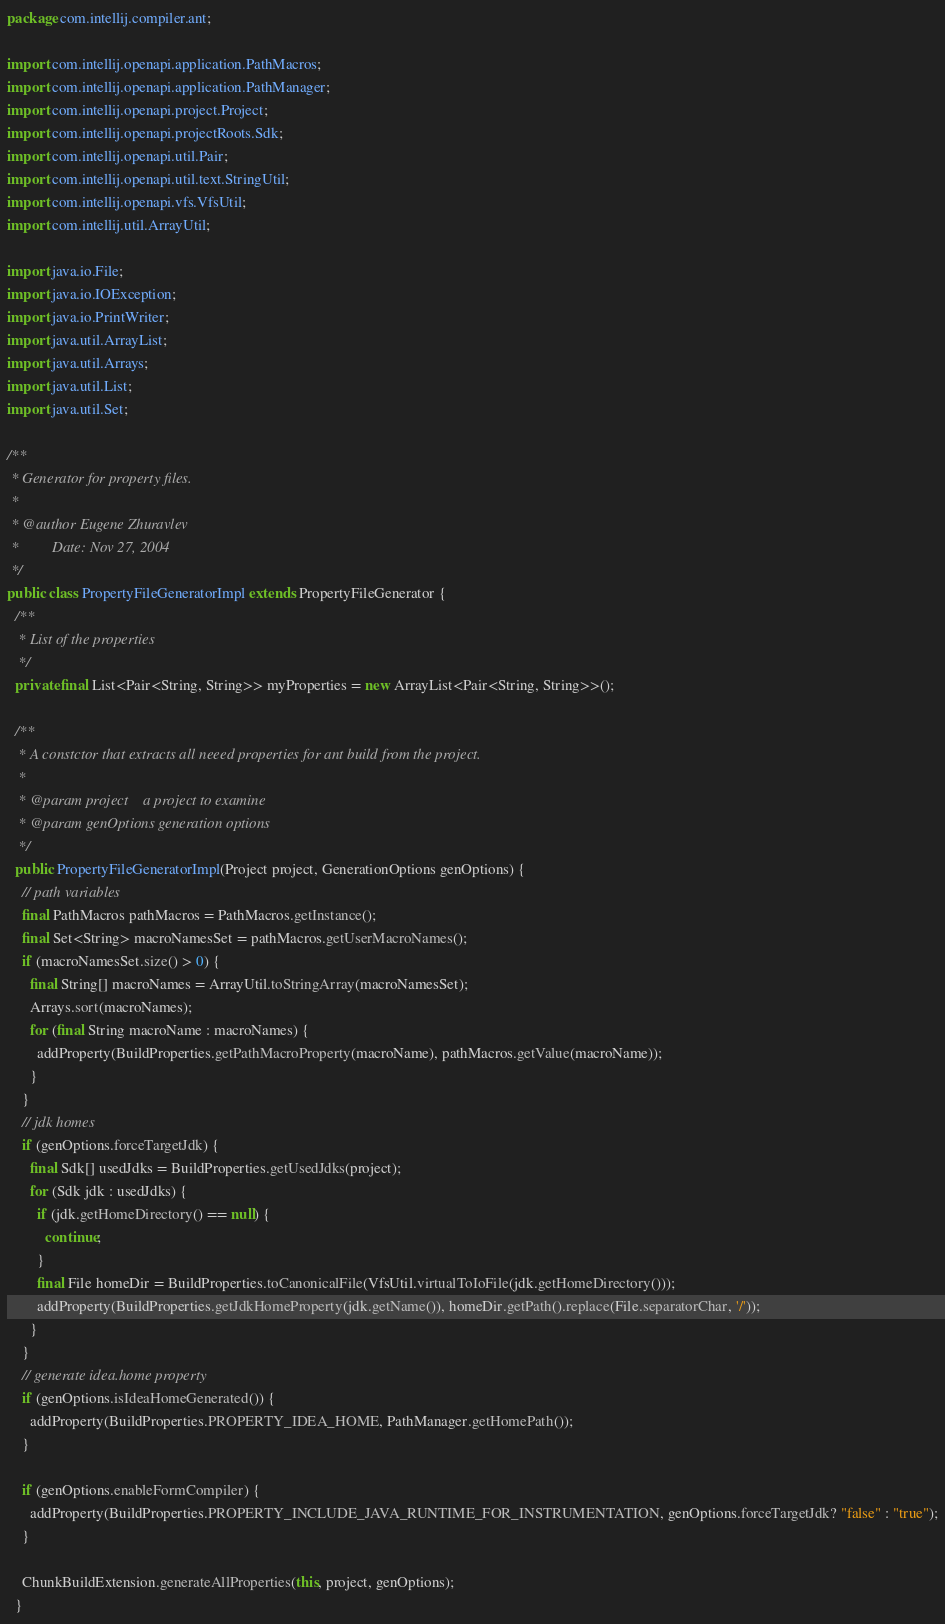Convert code to text. <code><loc_0><loc_0><loc_500><loc_500><_Java_>package com.intellij.compiler.ant;

import com.intellij.openapi.application.PathMacros;
import com.intellij.openapi.application.PathManager;
import com.intellij.openapi.project.Project;
import com.intellij.openapi.projectRoots.Sdk;
import com.intellij.openapi.util.Pair;
import com.intellij.openapi.util.text.StringUtil;
import com.intellij.openapi.vfs.VfsUtil;
import com.intellij.util.ArrayUtil;

import java.io.File;
import java.io.IOException;
import java.io.PrintWriter;
import java.util.ArrayList;
import java.util.Arrays;
import java.util.List;
import java.util.Set;

/**
 * Generator for property files.
 *
 * @author Eugene Zhuravlev
 *         Date: Nov 27, 2004
 */
public class PropertyFileGeneratorImpl extends PropertyFileGenerator {
  /**
   * List of the properties
   */
  private final List<Pair<String, String>> myProperties = new ArrayList<Pair<String, String>>();

  /**
   * A constctor that extracts all neeed properties for ant build from the project.
   *
   * @param project    a project to examine
   * @param genOptions generation options
   */
  public PropertyFileGeneratorImpl(Project project, GenerationOptions genOptions) {
    // path variables
    final PathMacros pathMacros = PathMacros.getInstance();
    final Set<String> macroNamesSet = pathMacros.getUserMacroNames();
    if (macroNamesSet.size() > 0) {
      final String[] macroNames = ArrayUtil.toStringArray(macroNamesSet);
      Arrays.sort(macroNames);
      for (final String macroName : macroNames) {
        addProperty(BuildProperties.getPathMacroProperty(macroName), pathMacros.getValue(macroName));
      }
    }
    // jdk homes
    if (genOptions.forceTargetJdk) {
      final Sdk[] usedJdks = BuildProperties.getUsedJdks(project);
      for (Sdk jdk : usedJdks) {
        if (jdk.getHomeDirectory() == null) {
          continue;
        }
        final File homeDir = BuildProperties.toCanonicalFile(VfsUtil.virtualToIoFile(jdk.getHomeDirectory()));
        addProperty(BuildProperties.getJdkHomeProperty(jdk.getName()), homeDir.getPath().replace(File.separatorChar, '/'));
      }
    }
    // generate idea.home property
    if (genOptions.isIdeaHomeGenerated()) {
      addProperty(BuildProperties.PROPERTY_IDEA_HOME, PathManager.getHomePath());
    }

    if (genOptions.enableFormCompiler) {
      addProperty(BuildProperties.PROPERTY_INCLUDE_JAVA_RUNTIME_FOR_INSTRUMENTATION, genOptions.forceTargetJdk? "false" : "true");
    }

    ChunkBuildExtension.generateAllProperties(this, project, genOptions);
  }
</code> 